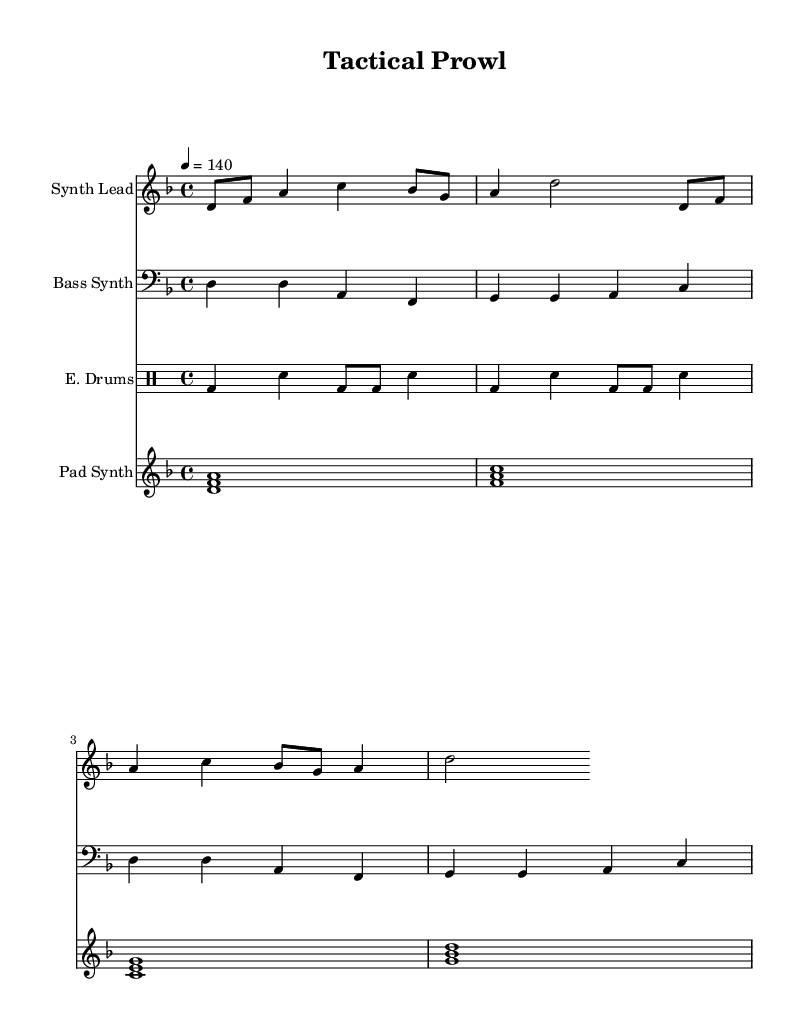What is the key signature of this music? The key signature is indicated by the presence of one flat (B♭) in the key signature section of the sheet music, which denotes D minor.
Answer: D minor What is the time signature of this music? The time signature is given at the beginning of the staff, showing 4 over 4, which means there are four beats in each measure and a quarter note gets the beat.
Answer: 4/4 What is the tempo marking in this music? The tempo marking shows "4 = 140," indicating that there are 140 beats per minute using quarter notes as the unit.
Answer: 140 How many measures are in the synth lead section? By counting the number of vertical lines (bar lines) in the synth lead part, we find there are four measures, as each measure is divided by such lines.
Answer: 4 Which instrument plays the pad synth? The instrument name shown on the staff indicates that the pad synth is the designated part written on that specific staff.
Answer: Pad Synth Explain the relationship between synth lead and bass synth in terms of harmony. The synth lead plays melodies with higher pitches (D, F, A, C) while the bass synth plays lower pitches (D, A, F), establishing a harmonic foundation. This is a common practice for creating depth in the sound by having a higher melodic line supported by a lower harmonic structure.
Answer: Melodic and harmonic support What rhythmic pattern do the drums follow? The drum pattern is formed through a combination of bass drums and snare hits, arranged in a specific sequence that consists of alternating bass drum and snare hits, creating a driving rhythm typical in electronic music.
Answer: Alternating bass and snare 